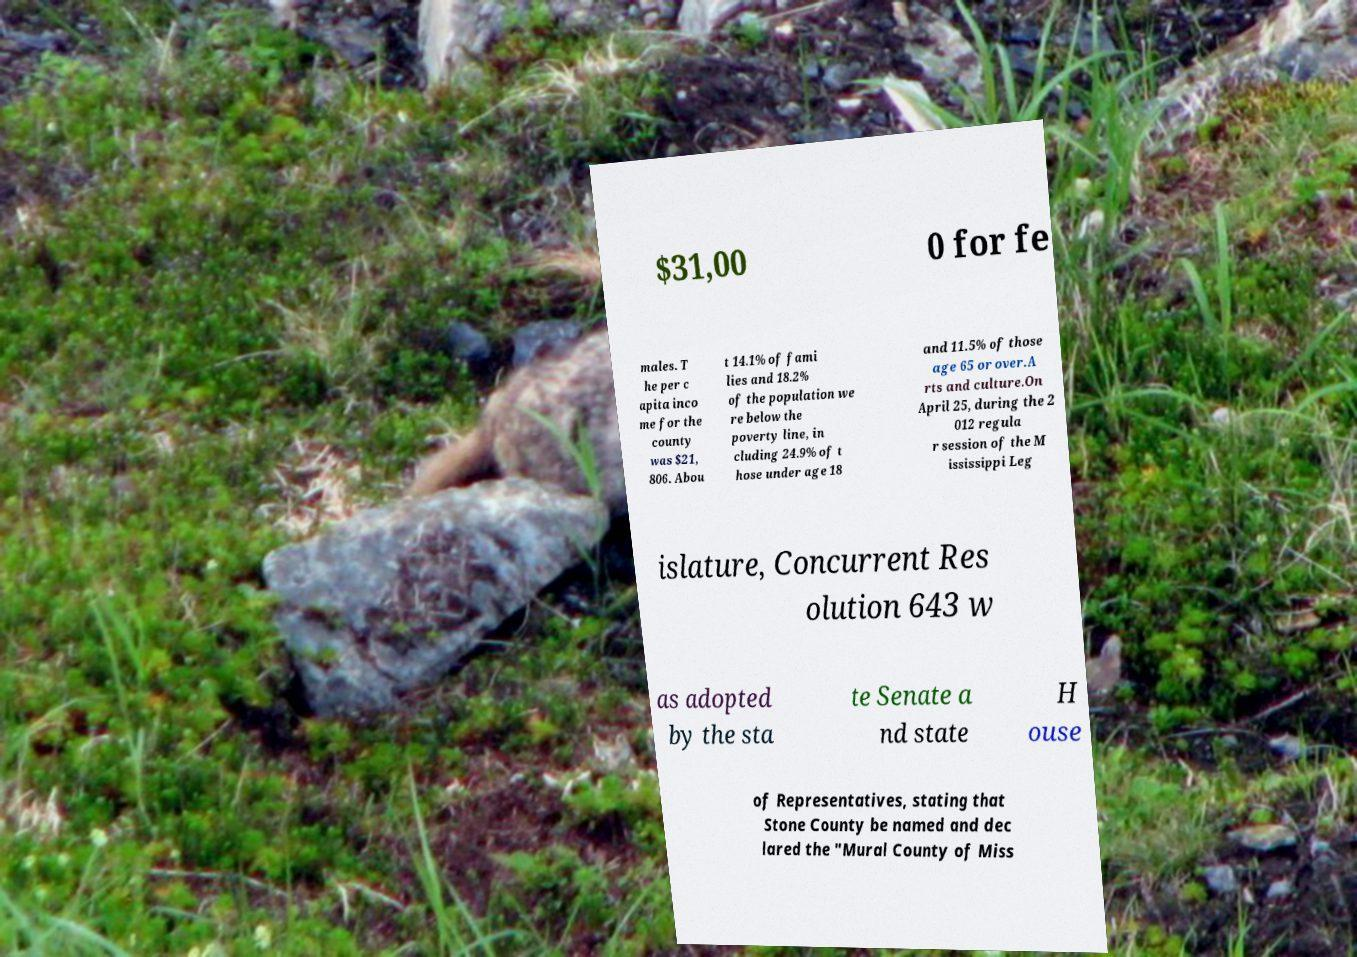Can you read and provide the text displayed in the image?This photo seems to have some interesting text. Can you extract and type it out for me? $31,00 0 for fe males. T he per c apita inco me for the county was $21, 806. Abou t 14.1% of fami lies and 18.2% of the population we re below the poverty line, in cluding 24.9% of t hose under age 18 and 11.5% of those age 65 or over.A rts and culture.On April 25, during the 2 012 regula r session of the M ississippi Leg islature, Concurrent Res olution 643 w as adopted by the sta te Senate a nd state H ouse of Representatives, stating that Stone County be named and dec lared the "Mural County of Miss 